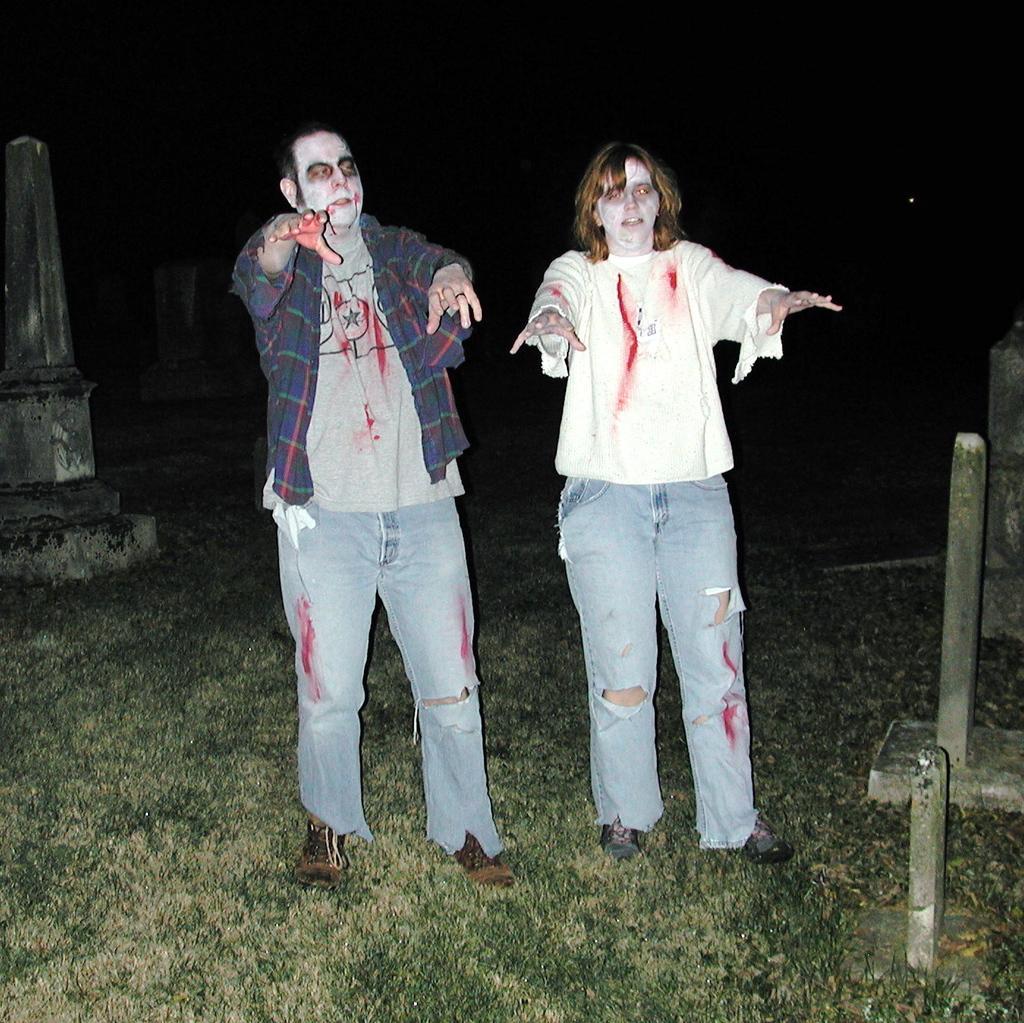How would you summarize this image in a sentence or two? In this image I can see grass ground and on it I can see two persons are standing. I can see both of them are wearing jeans, shoes and on their faces I can see face paintings. In the background I can see few tombstones and I can see black colour in the background. 